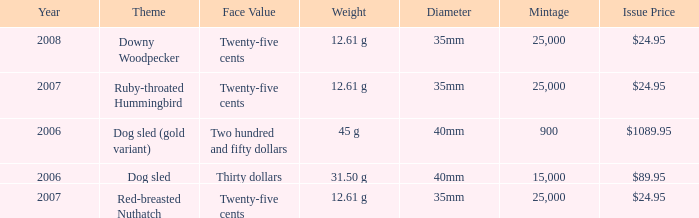What is the Year of the Coin with an Issue Price of $1089.95 and Mintage less than 900? None. 